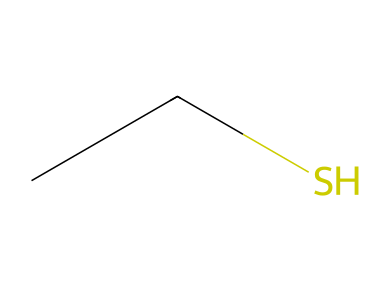How many carbon atoms are in ethanethiol? The SMILES representation "CCS" indicates that there are two 'C' characters, which correspond to two carbon atoms in the molecule.
Answer: 2 What type of bond connects the carbon atoms in ethanethiol? In the structure represented by "CCS," the two carbon atoms are connected by a single bond, as indicated by the lack of symbols that depict double or triple bonds.
Answer: single How many sulfur atoms are present in ethanethiol? The 'S' in the SMILES representation "CCS" indicates one sulfur atom is present in the compound.
Answer: 1 What functional group is present in ethanethiol? The presence of the 'S' in "CCS" suggests that the compound contains a thiol functional group, which is characterized by a sulfur atom bonded to a carbon atom and attached to at least one hydrogen atom.
Answer: thiol How many total atoms are in ethanethiol? Counting the atoms in the SMILES "CCS": 2 carbon atoms, 6 hydrogen atoms (derived from the two carbons), and 1 sulfur atom results in a total of 9 atoms.
Answer: 9 What is the molecular formula of ethanethiol? Based on the SMILES "CCS," the total number of each type of atom yields the molecular formula C2H6S, which includes 2 carbon atoms, 6 hydrogen atoms, and 1 sulfur atom.
Answer: C2H6S 